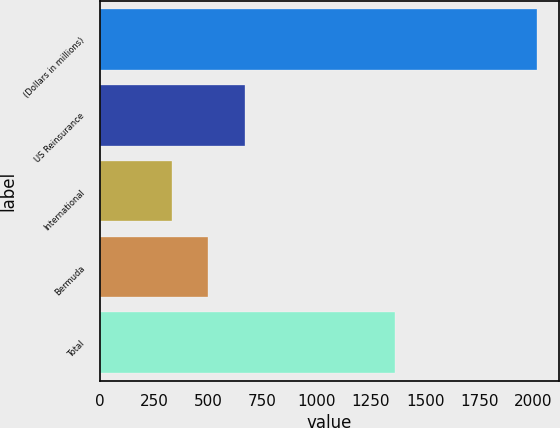Convert chart to OTSL. <chart><loc_0><loc_0><loc_500><loc_500><bar_chart><fcel>(Dollars in millions)<fcel>US Reinsurance<fcel>International<fcel>Bermuda<fcel>Total<nl><fcel>2018<fcel>668.08<fcel>330.6<fcel>499.34<fcel>1362.9<nl></chart> 